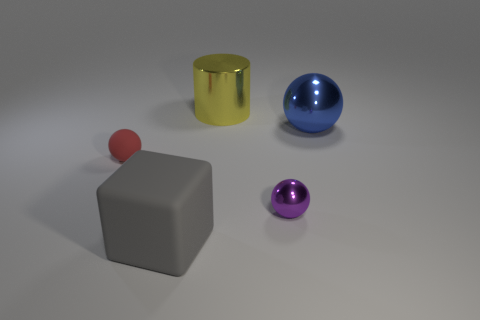There is a red rubber thing; is it the same size as the shiny ball in front of the blue thing?
Provide a short and direct response. Yes. Are there fewer blue metallic balls in front of the red ball than large metallic objects that are in front of the yellow thing?
Make the answer very short. Yes. There is a object that is on the right side of the small purple object; what is its size?
Offer a terse response. Large. Is the cylinder the same size as the purple sphere?
Give a very brief answer. No. How many objects are both right of the gray cube and in front of the yellow metal thing?
Provide a succinct answer. 2. What number of yellow objects are balls or tiny things?
Offer a terse response. 0. How many metallic things are cubes or blue spheres?
Your response must be concise. 1. Are any small purple metal objects visible?
Provide a succinct answer. Yes. Do the large blue object and the small metallic thing have the same shape?
Offer a very short reply. Yes. What number of tiny purple shiny things are to the right of the rubber object behind the matte object to the right of the tiny red thing?
Ensure brevity in your answer.  1. 